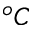<formula> <loc_0><loc_0><loc_500><loc_500>^ { o } C</formula> 